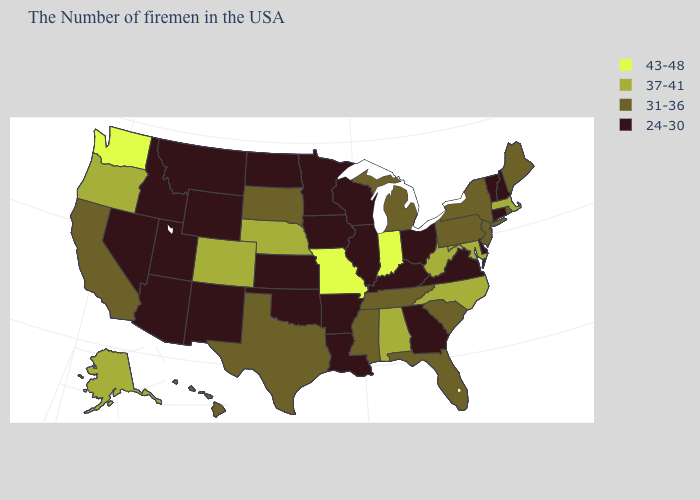Name the states that have a value in the range 31-36?
Be succinct. Maine, Rhode Island, New York, New Jersey, Pennsylvania, South Carolina, Florida, Michigan, Tennessee, Mississippi, Texas, South Dakota, California, Hawaii. Among the states that border Colorado , which have the lowest value?
Keep it brief. Kansas, Oklahoma, Wyoming, New Mexico, Utah, Arizona. Among the states that border Vermont , which have the lowest value?
Quick response, please. New Hampshire. Name the states that have a value in the range 31-36?
Short answer required. Maine, Rhode Island, New York, New Jersey, Pennsylvania, South Carolina, Florida, Michigan, Tennessee, Mississippi, Texas, South Dakota, California, Hawaii. Which states have the lowest value in the USA?
Write a very short answer. New Hampshire, Vermont, Connecticut, Delaware, Virginia, Ohio, Georgia, Kentucky, Wisconsin, Illinois, Louisiana, Arkansas, Minnesota, Iowa, Kansas, Oklahoma, North Dakota, Wyoming, New Mexico, Utah, Montana, Arizona, Idaho, Nevada. Does Washington have the highest value in the West?
Short answer required. Yes. Among the states that border Alabama , does Georgia have the lowest value?
Quick response, please. Yes. What is the highest value in the USA?
Short answer required. 43-48. What is the value of Mississippi?
Give a very brief answer. 31-36. What is the value of Connecticut?
Quick response, please. 24-30. Which states have the highest value in the USA?
Keep it brief. Indiana, Missouri, Washington. Does Virginia have the lowest value in the South?
Quick response, please. Yes. What is the lowest value in the South?
Be succinct. 24-30. What is the highest value in the West ?
Quick response, please. 43-48. Name the states that have a value in the range 37-41?
Quick response, please. Massachusetts, Maryland, North Carolina, West Virginia, Alabama, Nebraska, Colorado, Oregon, Alaska. 